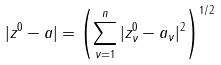<formula> <loc_0><loc_0><loc_500><loc_500>| z ^ { 0 } - a | = \left ( \sum _ { \nu = 1 } ^ { n } | z _ { \nu } ^ { 0 } - a _ { \nu } | ^ { 2 } \right ) ^ { 1 / 2 }</formula> 